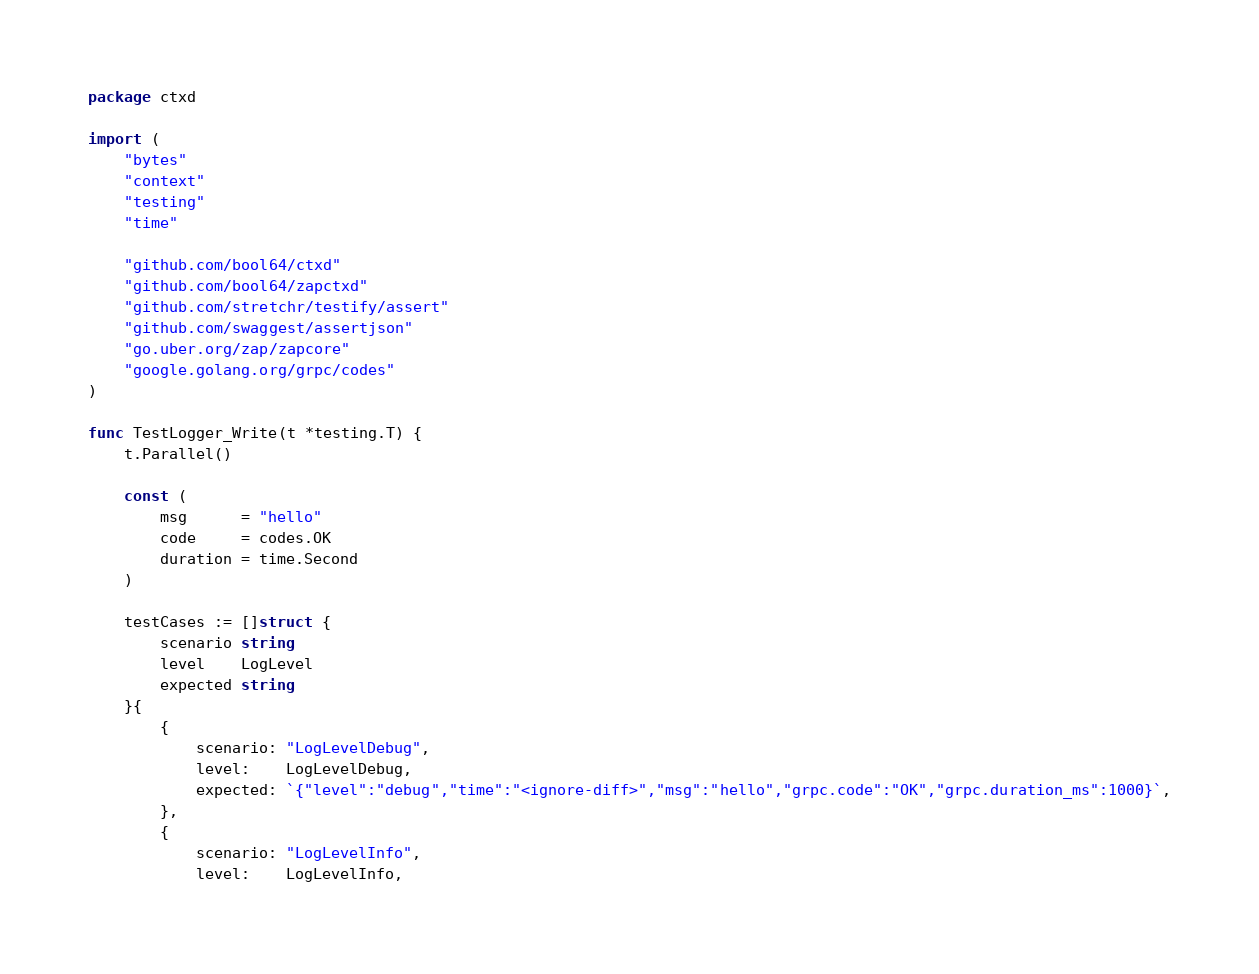<code> <loc_0><loc_0><loc_500><loc_500><_Go_>package ctxd

import (
	"bytes"
	"context"
	"testing"
	"time"

	"github.com/bool64/ctxd"
	"github.com/bool64/zapctxd"
	"github.com/stretchr/testify/assert"
	"github.com/swaggest/assertjson"
	"go.uber.org/zap/zapcore"
	"google.golang.org/grpc/codes"
)

func TestLogger_Write(t *testing.T) {
	t.Parallel()

	const (
		msg      = "hello"
		code     = codes.OK
		duration = time.Second
	)

	testCases := []struct {
		scenario string
		level    LogLevel
		expected string
	}{
		{
			scenario: "LogLevelDebug",
			level:    LogLevelDebug,
			expected: `{"level":"debug","time":"<ignore-diff>","msg":"hello","grpc.code":"OK","grpc.duration_ms":1000}`,
		},
		{
			scenario: "LogLevelInfo",
			level:    LogLevelInfo,</code> 